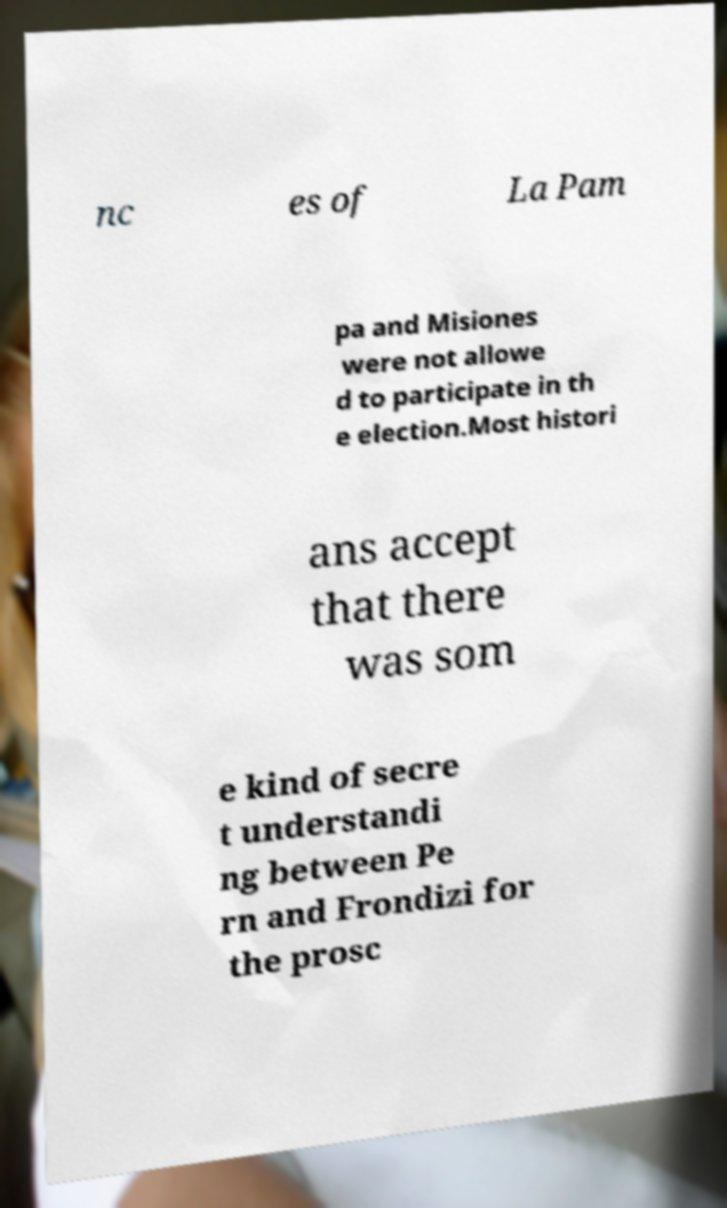Can you accurately transcribe the text from the provided image for me? nc es of La Pam pa and Misiones were not allowe d to participate in th e election.Most histori ans accept that there was som e kind of secre t understandi ng between Pe rn and Frondizi for the prosc 